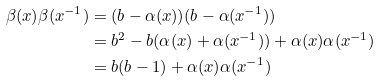Convert formula to latex. <formula><loc_0><loc_0><loc_500><loc_500>\beta ( x ) \beta ( x ^ { - 1 } ) & = ( b - \alpha ( x ) ) ( b - \alpha ( x ^ { - 1 } ) ) \\ & = b ^ { 2 } - b ( \alpha ( x ) + \alpha ( x ^ { - 1 } ) ) + \alpha ( x ) \alpha ( x ^ { - 1 } ) \\ & = b ( b - 1 ) + \alpha ( x ) \alpha ( x ^ { - 1 } )</formula> 